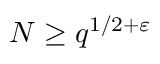Convert formula to latex. <formula><loc_0><loc_0><loc_500><loc_500>N \geq q ^ { 1 / 2 + \varepsilon }</formula> 